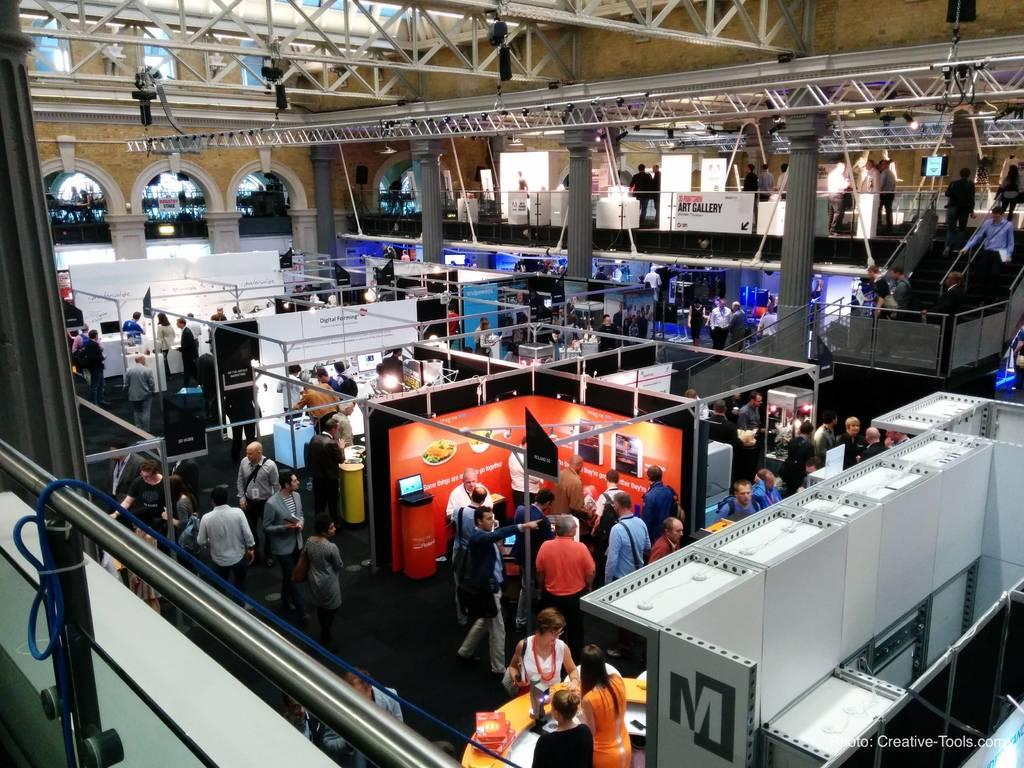How many people are present in the image? There are people in the image, but the exact number is not specified. What can be seen on the boards in the image? The boards in the image have text and images on them. What type of display devices are present in the image? There are screens in the image. What architectural feature is present in the image? There are stairs in the image. What safety feature is present in the image? There is railing in the image. What type of material is used for some objects in the image? There are metal objects in the image. What vertical structures are present in the image? There are poles in the image. What type of juice is being served to the army in the image? There is no army or juice present in the image. What time of day is depicted in the image? The time of day is not specified in the image. 